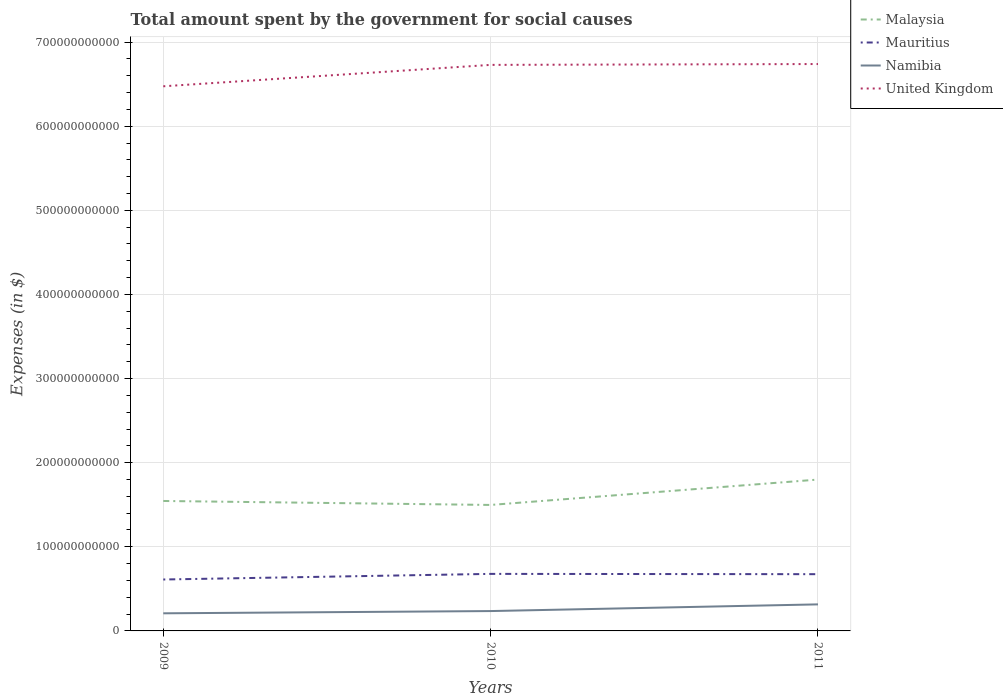How many different coloured lines are there?
Provide a succinct answer. 4. Does the line corresponding to Mauritius intersect with the line corresponding to United Kingdom?
Provide a succinct answer. No. Across all years, what is the maximum amount spent for social causes by the government in Malaysia?
Give a very brief answer. 1.50e+11. In which year was the amount spent for social causes by the government in United Kingdom maximum?
Provide a succinct answer. 2009. What is the total amount spent for social causes by the government in Malaysia in the graph?
Offer a terse response. -3.02e+1. What is the difference between the highest and the second highest amount spent for social causes by the government in United Kingdom?
Provide a succinct answer. 2.65e+1. What is the difference between the highest and the lowest amount spent for social causes by the government in Namibia?
Offer a terse response. 1. How many years are there in the graph?
Your response must be concise. 3. What is the difference between two consecutive major ticks on the Y-axis?
Your answer should be very brief. 1.00e+11. Are the values on the major ticks of Y-axis written in scientific E-notation?
Make the answer very short. No. Where does the legend appear in the graph?
Make the answer very short. Top right. How are the legend labels stacked?
Ensure brevity in your answer.  Vertical. What is the title of the graph?
Provide a short and direct response. Total amount spent by the government for social causes. What is the label or title of the X-axis?
Keep it short and to the point. Years. What is the label or title of the Y-axis?
Provide a short and direct response. Expenses (in $). What is the Expenses (in $) in Malaysia in 2009?
Provide a succinct answer. 1.54e+11. What is the Expenses (in $) in Mauritius in 2009?
Make the answer very short. 6.11e+1. What is the Expenses (in $) in Namibia in 2009?
Ensure brevity in your answer.  2.09e+1. What is the Expenses (in $) in United Kingdom in 2009?
Offer a very short reply. 6.47e+11. What is the Expenses (in $) of Malaysia in 2010?
Provide a short and direct response. 1.50e+11. What is the Expenses (in $) in Mauritius in 2010?
Offer a terse response. 6.78e+1. What is the Expenses (in $) of Namibia in 2010?
Make the answer very short. 2.36e+1. What is the Expenses (in $) of United Kingdom in 2010?
Make the answer very short. 6.73e+11. What is the Expenses (in $) in Malaysia in 2011?
Your answer should be compact. 1.80e+11. What is the Expenses (in $) in Mauritius in 2011?
Offer a terse response. 6.75e+1. What is the Expenses (in $) in Namibia in 2011?
Ensure brevity in your answer.  3.16e+1. What is the Expenses (in $) in United Kingdom in 2011?
Make the answer very short. 6.74e+11. Across all years, what is the maximum Expenses (in $) in Malaysia?
Make the answer very short. 1.80e+11. Across all years, what is the maximum Expenses (in $) in Mauritius?
Ensure brevity in your answer.  6.78e+1. Across all years, what is the maximum Expenses (in $) of Namibia?
Offer a very short reply. 3.16e+1. Across all years, what is the maximum Expenses (in $) in United Kingdom?
Give a very brief answer. 6.74e+11. Across all years, what is the minimum Expenses (in $) in Malaysia?
Give a very brief answer. 1.50e+11. Across all years, what is the minimum Expenses (in $) in Mauritius?
Ensure brevity in your answer.  6.11e+1. Across all years, what is the minimum Expenses (in $) of Namibia?
Provide a short and direct response. 2.09e+1. Across all years, what is the minimum Expenses (in $) in United Kingdom?
Offer a terse response. 6.47e+11. What is the total Expenses (in $) of Malaysia in the graph?
Give a very brief answer. 4.84e+11. What is the total Expenses (in $) of Mauritius in the graph?
Offer a terse response. 1.96e+11. What is the total Expenses (in $) in Namibia in the graph?
Your response must be concise. 7.61e+1. What is the total Expenses (in $) of United Kingdom in the graph?
Offer a terse response. 1.99e+12. What is the difference between the Expenses (in $) of Malaysia in 2009 and that in 2010?
Your answer should be compact. 4.72e+09. What is the difference between the Expenses (in $) of Mauritius in 2009 and that in 2010?
Your answer should be compact. -6.67e+09. What is the difference between the Expenses (in $) in Namibia in 2009 and that in 2010?
Ensure brevity in your answer.  -2.68e+09. What is the difference between the Expenses (in $) in United Kingdom in 2009 and that in 2010?
Ensure brevity in your answer.  -2.55e+1. What is the difference between the Expenses (in $) of Malaysia in 2009 and that in 2011?
Make the answer very short. -2.54e+1. What is the difference between the Expenses (in $) in Mauritius in 2009 and that in 2011?
Provide a succinct answer. -6.32e+09. What is the difference between the Expenses (in $) of Namibia in 2009 and that in 2011?
Keep it short and to the point. -1.06e+1. What is the difference between the Expenses (in $) of United Kingdom in 2009 and that in 2011?
Your response must be concise. -2.65e+1. What is the difference between the Expenses (in $) of Malaysia in 2010 and that in 2011?
Provide a succinct answer. -3.02e+1. What is the difference between the Expenses (in $) of Mauritius in 2010 and that in 2011?
Offer a terse response. 3.55e+08. What is the difference between the Expenses (in $) of Namibia in 2010 and that in 2011?
Provide a succinct answer. -7.94e+09. What is the difference between the Expenses (in $) of United Kingdom in 2010 and that in 2011?
Give a very brief answer. -1.00e+09. What is the difference between the Expenses (in $) in Malaysia in 2009 and the Expenses (in $) in Mauritius in 2010?
Offer a terse response. 8.67e+1. What is the difference between the Expenses (in $) of Malaysia in 2009 and the Expenses (in $) of Namibia in 2010?
Your answer should be very brief. 1.31e+11. What is the difference between the Expenses (in $) of Malaysia in 2009 and the Expenses (in $) of United Kingdom in 2010?
Ensure brevity in your answer.  -5.18e+11. What is the difference between the Expenses (in $) in Mauritius in 2009 and the Expenses (in $) in Namibia in 2010?
Ensure brevity in your answer.  3.75e+1. What is the difference between the Expenses (in $) in Mauritius in 2009 and the Expenses (in $) in United Kingdom in 2010?
Give a very brief answer. -6.12e+11. What is the difference between the Expenses (in $) in Namibia in 2009 and the Expenses (in $) in United Kingdom in 2010?
Offer a terse response. -6.52e+11. What is the difference between the Expenses (in $) in Malaysia in 2009 and the Expenses (in $) in Mauritius in 2011?
Keep it short and to the point. 8.70e+1. What is the difference between the Expenses (in $) of Malaysia in 2009 and the Expenses (in $) of Namibia in 2011?
Offer a very short reply. 1.23e+11. What is the difference between the Expenses (in $) of Malaysia in 2009 and the Expenses (in $) of United Kingdom in 2011?
Provide a short and direct response. -5.19e+11. What is the difference between the Expenses (in $) in Mauritius in 2009 and the Expenses (in $) in Namibia in 2011?
Give a very brief answer. 2.96e+1. What is the difference between the Expenses (in $) of Mauritius in 2009 and the Expenses (in $) of United Kingdom in 2011?
Your answer should be very brief. -6.13e+11. What is the difference between the Expenses (in $) of Namibia in 2009 and the Expenses (in $) of United Kingdom in 2011?
Provide a short and direct response. -6.53e+11. What is the difference between the Expenses (in $) in Malaysia in 2010 and the Expenses (in $) in Mauritius in 2011?
Make the answer very short. 8.23e+1. What is the difference between the Expenses (in $) in Malaysia in 2010 and the Expenses (in $) in Namibia in 2011?
Provide a succinct answer. 1.18e+11. What is the difference between the Expenses (in $) in Malaysia in 2010 and the Expenses (in $) in United Kingdom in 2011?
Make the answer very short. -5.24e+11. What is the difference between the Expenses (in $) of Mauritius in 2010 and the Expenses (in $) of Namibia in 2011?
Your response must be concise. 3.63e+1. What is the difference between the Expenses (in $) in Mauritius in 2010 and the Expenses (in $) in United Kingdom in 2011?
Make the answer very short. -6.06e+11. What is the difference between the Expenses (in $) in Namibia in 2010 and the Expenses (in $) in United Kingdom in 2011?
Your response must be concise. -6.50e+11. What is the average Expenses (in $) in Malaysia per year?
Your answer should be very brief. 1.61e+11. What is the average Expenses (in $) of Mauritius per year?
Your answer should be compact. 6.55e+1. What is the average Expenses (in $) of Namibia per year?
Your answer should be compact. 2.54e+1. What is the average Expenses (in $) of United Kingdom per year?
Ensure brevity in your answer.  6.65e+11. In the year 2009, what is the difference between the Expenses (in $) of Malaysia and Expenses (in $) of Mauritius?
Provide a succinct answer. 9.34e+1. In the year 2009, what is the difference between the Expenses (in $) of Malaysia and Expenses (in $) of Namibia?
Your response must be concise. 1.34e+11. In the year 2009, what is the difference between the Expenses (in $) in Malaysia and Expenses (in $) in United Kingdom?
Your answer should be very brief. -4.93e+11. In the year 2009, what is the difference between the Expenses (in $) in Mauritius and Expenses (in $) in Namibia?
Your answer should be compact. 4.02e+1. In the year 2009, what is the difference between the Expenses (in $) in Mauritius and Expenses (in $) in United Kingdom?
Ensure brevity in your answer.  -5.86e+11. In the year 2009, what is the difference between the Expenses (in $) of Namibia and Expenses (in $) of United Kingdom?
Offer a very short reply. -6.27e+11. In the year 2010, what is the difference between the Expenses (in $) in Malaysia and Expenses (in $) in Mauritius?
Ensure brevity in your answer.  8.20e+1. In the year 2010, what is the difference between the Expenses (in $) of Malaysia and Expenses (in $) of Namibia?
Your answer should be very brief. 1.26e+11. In the year 2010, what is the difference between the Expenses (in $) of Malaysia and Expenses (in $) of United Kingdom?
Keep it short and to the point. -5.23e+11. In the year 2010, what is the difference between the Expenses (in $) of Mauritius and Expenses (in $) of Namibia?
Provide a succinct answer. 4.42e+1. In the year 2010, what is the difference between the Expenses (in $) of Mauritius and Expenses (in $) of United Kingdom?
Your answer should be very brief. -6.05e+11. In the year 2010, what is the difference between the Expenses (in $) in Namibia and Expenses (in $) in United Kingdom?
Make the answer very short. -6.49e+11. In the year 2011, what is the difference between the Expenses (in $) in Malaysia and Expenses (in $) in Mauritius?
Give a very brief answer. 1.12e+11. In the year 2011, what is the difference between the Expenses (in $) of Malaysia and Expenses (in $) of Namibia?
Your answer should be compact. 1.48e+11. In the year 2011, what is the difference between the Expenses (in $) of Malaysia and Expenses (in $) of United Kingdom?
Your answer should be compact. -4.94e+11. In the year 2011, what is the difference between the Expenses (in $) of Mauritius and Expenses (in $) of Namibia?
Keep it short and to the point. 3.59e+1. In the year 2011, what is the difference between the Expenses (in $) in Mauritius and Expenses (in $) in United Kingdom?
Your answer should be very brief. -6.06e+11. In the year 2011, what is the difference between the Expenses (in $) of Namibia and Expenses (in $) of United Kingdom?
Offer a very short reply. -6.42e+11. What is the ratio of the Expenses (in $) of Malaysia in 2009 to that in 2010?
Make the answer very short. 1.03. What is the ratio of the Expenses (in $) of Mauritius in 2009 to that in 2010?
Ensure brevity in your answer.  0.9. What is the ratio of the Expenses (in $) of Namibia in 2009 to that in 2010?
Your answer should be very brief. 0.89. What is the ratio of the Expenses (in $) of United Kingdom in 2009 to that in 2010?
Provide a succinct answer. 0.96. What is the ratio of the Expenses (in $) in Malaysia in 2009 to that in 2011?
Provide a short and direct response. 0.86. What is the ratio of the Expenses (in $) of Mauritius in 2009 to that in 2011?
Provide a short and direct response. 0.91. What is the ratio of the Expenses (in $) in Namibia in 2009 to that in 2011?
Offer a very short reply. 0.66. What is the ratio of the Expenses (in $) of United Kingdom in 2009 to that in 2011?
Provide a succinct answer. 0.96. What is the ratio of the Expenses (in $) of Malaysia in 2010 to that in 2011?
Keep it short and to the point. 0.83. What is the ratio of the Expenses (in $) in Namibia in 2010 to that in 2011?
Make the answer very short. 0.75. What is the ratio of the Expenses (in $) of United Kingdom in 2010 to that in 2011?
Keep it short and to the point. 1. What is the difference between the highest and the second highest Expenses (in $) of Malaysia?
Make the answer very short. 2.54e+1. What is the difference between the highest and the second highest Expenses (in $) in Mauritius?
Make the answer very short. 3.55e+08. What is the difference between the highest and the second highest Expenses (in $) of Namibia?
Give a very brief answer. 7.94e+09. What is the difference between the highest and the second highest Expenses (in $) of United Kingdom?
Make the answer very short. 1.00e+09. What is the difference between the highest and the lowest Expenses (in $) in Malaysia?
Your answer should be compact. 3.02e+1. What is the difference between the highest and the lowest Expenses (in $) of Mauritius?
Provide a short and direct response. 6.67e+09. What is the difference between the highest and the lowest Expenses (in $) of Namibia?
Provide a succinct answer. 1.06e+1. What is the difference between the highest and the lowest Expenses (in $) in United Kingdom?
Ensure brevity in your answer.  2.65e+1. 